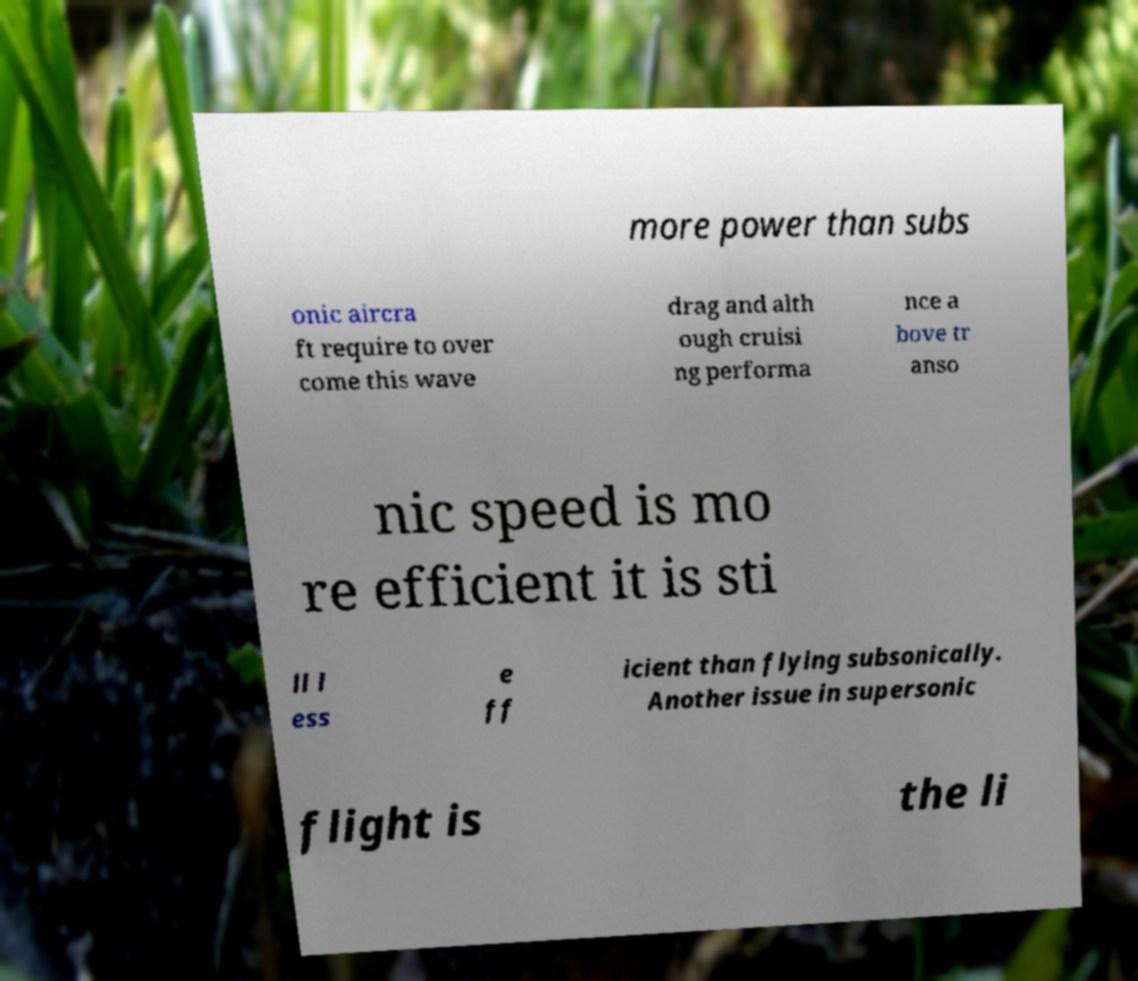Please read and relay the text visible in this image. What does it say? more power than subs onic aircra ft require to over come this wave drag and alth ough cruisi ng performa nce a bove tr anso nic speed is mo re efficient it is sti ll l ess e ff icient than flying subsonically. Another issue in supersonic flight is the li 